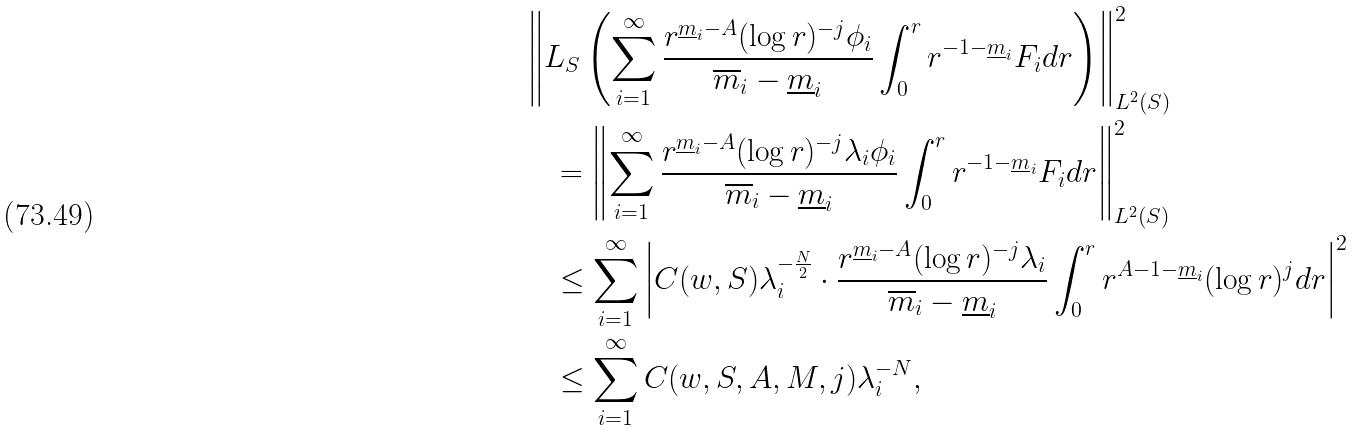<formula> <loc_0><loc_0><loc_500><loc_500>& \left \| L _ { S } \left ( \sum _ { i = 1 } ^ { \infty } \frac { r ^ { \underline { m } _ { i } - A } ( \log r ) ^ { - j } \phi _ { i } } { \overline { m } _ { i } - \underline { m } _ { i } } \int _ { 0 } ^ { r } r ^ { - 1 - \underline { m } _ { i } } F _ { i } d r \right ) \right \| ^ { 2 } _ { L ^ { 2 } ( S ) } \\ & \quad = \left \| \sum _ { i = 1 } ^ { \infty } \frac { r ^ { \underline { m } _ { i } - A } ( \log r ) ^ { - j } \lambda _ { i } \phi _ { i } } { \overline { m } _ { i } - \underline { m } _ { i } } \int _ { 0 } ^ { r } r ^ { - 1 - \underline { m } _ { i } } F _ { i } d r \right \| ^ { 2 } _ { L ^ { 2 } ( S ) } \\ & \quad \leq \sum _ { i = 1 } ^ { \infty } \left | C ( w , S ) \lambda _ { i } ^ { - \frac { N } { 2 } } \cdot \frac { r ^ { \underline { m } _ { i } - A } ( \log r ) ^ { - j } \lambda _ { i } } { \overline { m } _ { i } - \underline { m } _ { i } } \int _ { 0 } ^ { r } r ^ { A - 1 - \underline { m } _ { i } } ( \log r ) ^ { j } d r \right | ^ { 2 } \\ & \quad \leq \sum _ { i = 1 } ^ { \infty } C ( w , S , A , M , j ) \lambda _ { i } ^ { - N } ,</formula> 